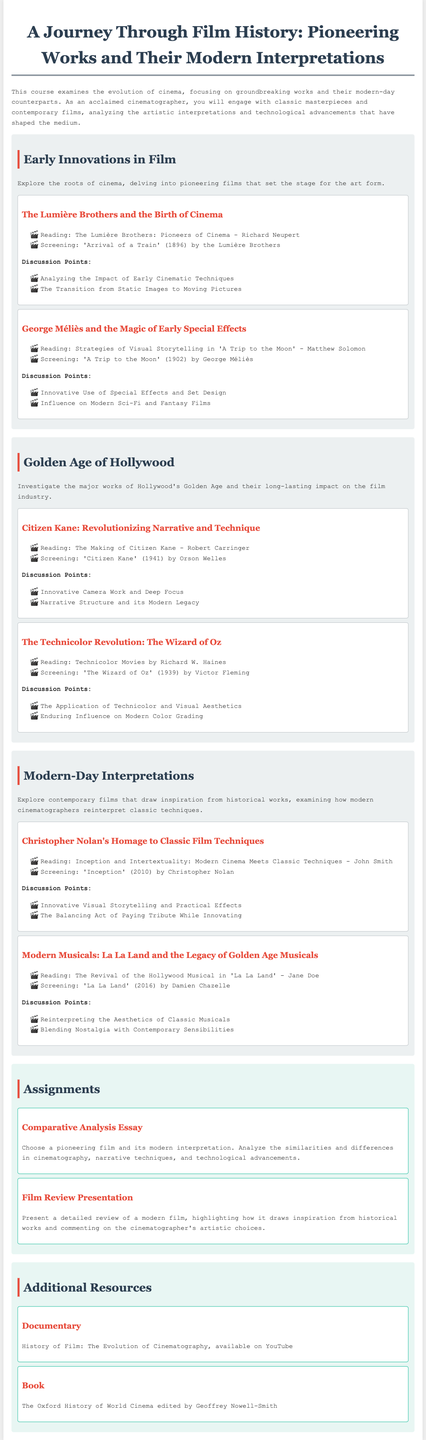What is the title of the course? The title of the course is presented at the top of the document.
Answer: A Journey Through Film History: Pioneering Works and Their Modern Interpretations Who directed 'Citizen Kane'? 'Citizen Kane' is attributed to Orson Welles, as stated in the syllabus.
Answer: Orson Welles In which year was 'A Trip to the Moon' released? The release year of 'A Trip to the Moon' is mentioned alongside the screening details.
Answer: 1902 What is one discussion point for the topic on George Méliès? The discussion points for George Méliès's topic are listed directly under it.
Answer: Innovative Use of Special Effects and Set Design How many major modules are in the syllabus? The modules are clearly sectioned, and by counting the distinct headings, we find the total.
Answer: Three What type of essay is an assignment in the course? The type of essay is detailed under the assignments section, specifying the comparative nature.
Answer: Comparative Analysis Essay What color is used for the headings in the document? The color of the headings is mentioned in the styling details present in the document.
Answer: #2c3e50 Who is the author of the reading on 'Inception'? The reading materials list the authors next to their respective topics, revealing the author for 'Inception'.
Answer: John Smith 